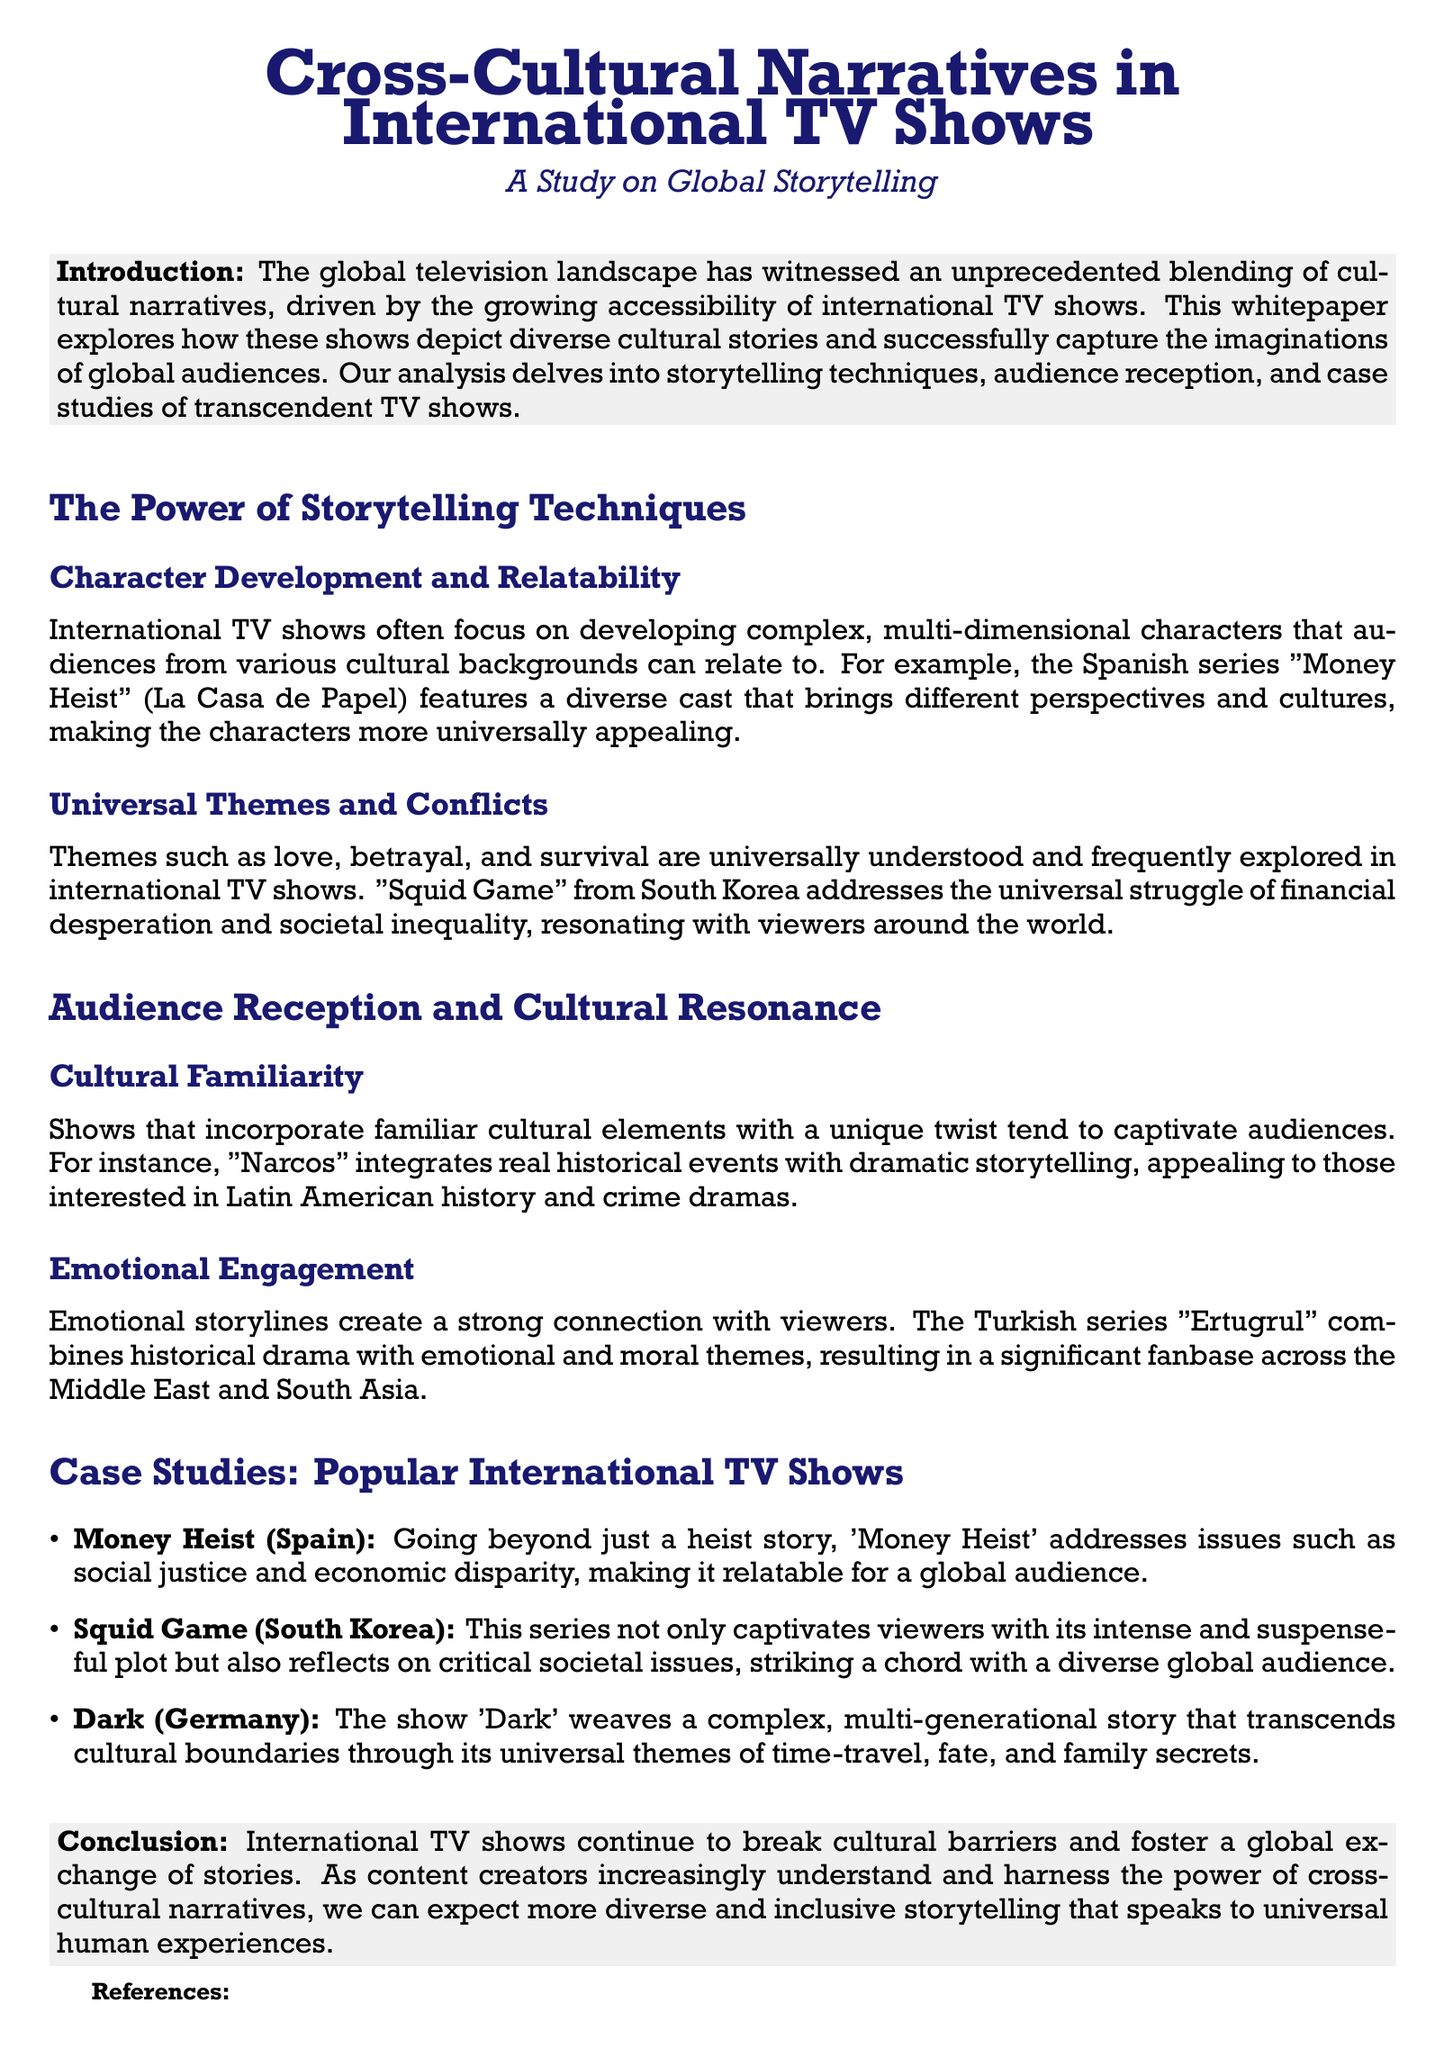what is the title of the whitepaper? The title of the whitepaper is given in the document header, which introduces the main topic of discussion.
Answer: Cross-Cultural Narratives in International TV Shows who is the author of the whitepaper? The document does not specify an author, thus this information is not provided.
Answer: Not specified name one international TV show that focuses on character relatability. The document provides examples of shows that emphasize character development and relatability.
Answer: Money Heist what theme is extensively explored in "Squid Game"? The whitepaper discusses universal themes that are central to various TV shows, mentioning specific themes addressed in "Squid Game".
Answer: Financial desperation which show integrates real historical events with its storytelling? The analysis in the document includes a show that combines actual historical narratives with drama, enhancing its appeal.
Answer: Narcos how many case studies are featured in the whitepaper? The whitepaper enumerates case studies that illustrate its findings regarding cross-cultural narratives in popular TV shows.
Answer: Three what is the main conclusion of the whitepaper? The conclusion section summarizes the overall findings and implications related to international TV shows and their cultural narratives.
Answer: Break cultural barriers what emotion does the Turkish series "Ertugrul" focus on? The document highlights the emotional themes in "Ertugrul," contributing to its popularity and audience engagement.
Answer: Emotional and moral themes which colors are used for headings in the document? The document specifies a color for sections that is consistent throughout, giving it a unique presentation.
Answer: Mystery blue 